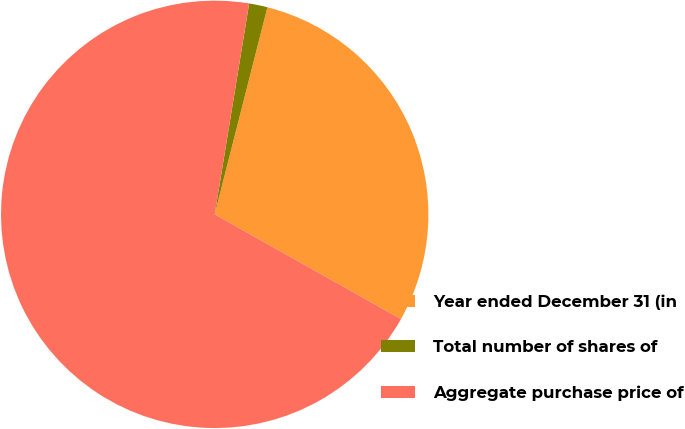<chart> <loc_0><loc_0><loc_500><loc_500><pie_chart><fcel>Year ended December 31 (in<fcel>Total number of shares of<fcel>Aggregate purchase price of<nl><fcel>29.18%<fcel>1.39%<fcel>69.42%<nl></chart> 